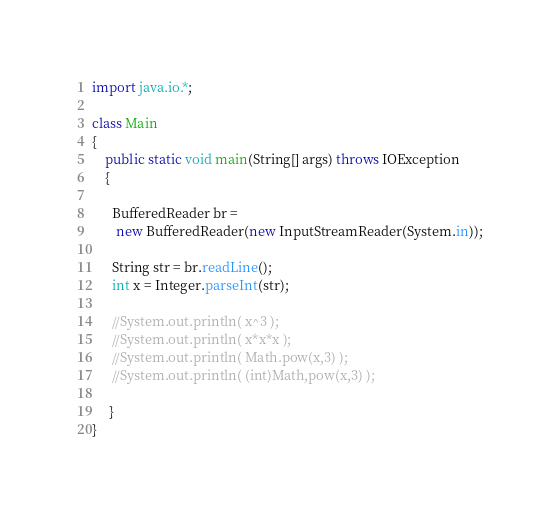Convert code to text. <code><loc_0><loc_0><loc_500><loc_500><_Java_>import java.io.*;

class Main
{
    public static void main(String[] args) throws IOException
    {

      BufferedReader br =
       new BufferedReader(new InputStreamReader(System.in));

      String str = br.readLine();
      int x = Integer.parseInt(str);

      //System.out.println( x^3 );
      //System.out.println( x*x*x );
      //System.out.println( Math.pow(x,3) );
      //System.out.println( (int)Math,pow(x,3) );

     }
}</code> 